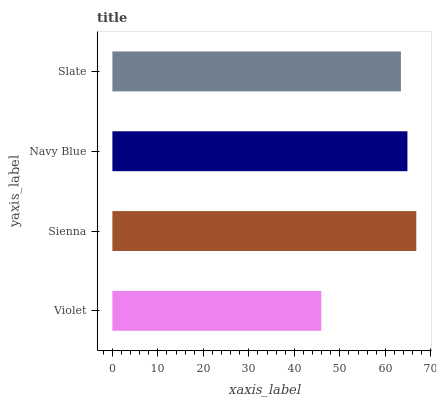Is Violet the minimum?
Answer yes or no. Yes. Is Sienna the maximum?
Answer yes or no. Yes. Is Navy Blue the minimum?
Answer yes or no. No. Is Navy Blue the maximum?
Answer yes or no. No. Is Sienna greater than Navy Blue?
Answer yes or no. Yes. Is Navy Blue less than Sienna?
Answer yes or no. Yes. Is Navy Blue greater than Sienna?
Answer yes or no. No. Is Sienna less than Navy Blue?
Answer yes or no. No. Is Navy Blue the high median?
Answer yes or no. Yes. Is Slate the low median?
Answer yes or no. Yes. Is Slate the high median?
Answer yes or no. No. Is Violet the low median?
Answer yes or no. No. 